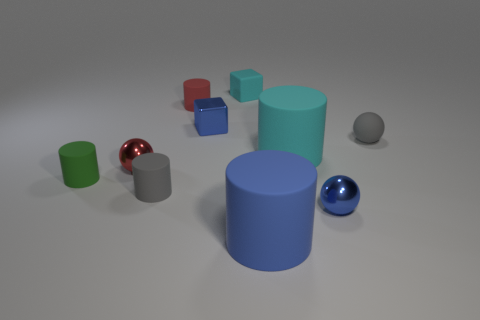Does the matte ball have the same color as the small rubber object in front of the tiny green object?
Offer a very short reply. Yes. Is the number of small red rubber cylinders less than the number of small gray shiny spheres?
Your answer should be compact. No. Do the metal thing right of the blue cube and the metallic block have the same color?
Offer a terse response. Yes. How many cyan metallic cubes are the same size as the cyan cylinder?
Make the answer very short. 0. Is there a cylinder of the same color as the matte cube?
Your response must be concise. Yes. Are the red cylinder and the small cyan cube made of the same material?
Your answer should be compact. Yes. What number of other blue things are the same shape as the blue matte object?
Your answer should be very brief. 0. There is a blue thing that is the same material as the tiny blue block; what shape is it?
Provide a succinct answer. Sphere. There is a rubber cylinder that is on the left side of the small sphere left of the tiny metallic block; what is its color?
Make the answer very short. Green. There is a tiny blue thing that is to the right of the tiny blue thing that is behind the green matte cylinder; what is its material?
Your response must be concise. Metal. 